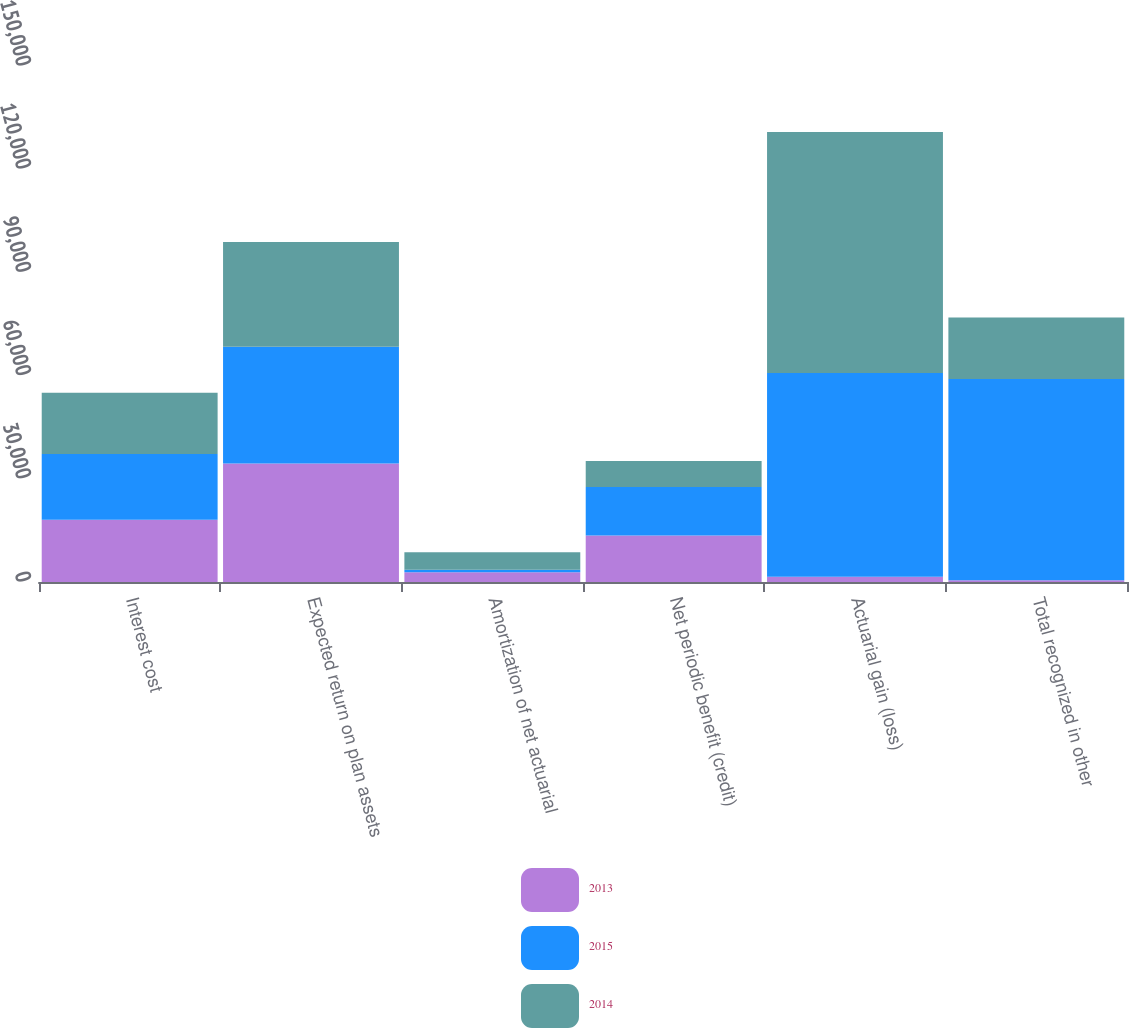Convert chart. <chart><loc_0><loc_0><loc_500><loc_500><stacked_bar_chart><ecel><fcel>Interest cost<fcel>Expected return on plan assets<fcel>Amortization of net actuarial<fcel>Net periodic benefit (credit)<fcel>Actuarial gain (loss)<fcel>Total recognized in other<nl><fcel>2013<fcel>18102<fcel>34432<fcel>2828<fcel>13502<fcel>1508<fcel>505<nl><fcel>2015<fcel>19073<fcel>33942<fcel>763<fcel>14106<fcel>59272<fcel>58509<nl><fcel>2014<fcel>17860<fcel>30480<fcel>5078<fcel>7542<fcel>70065<fcel>17860<nl></chart> 